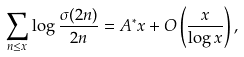<formula> <loc_0><loc_0><loc_500><loc_500>\sum _ { n \leq x } \log \frac { \sigma ( 2 n ) } { 2 n } = A ^ { * } x + O \left ( \frac { x } { \log x } \right ) ,</formula> 